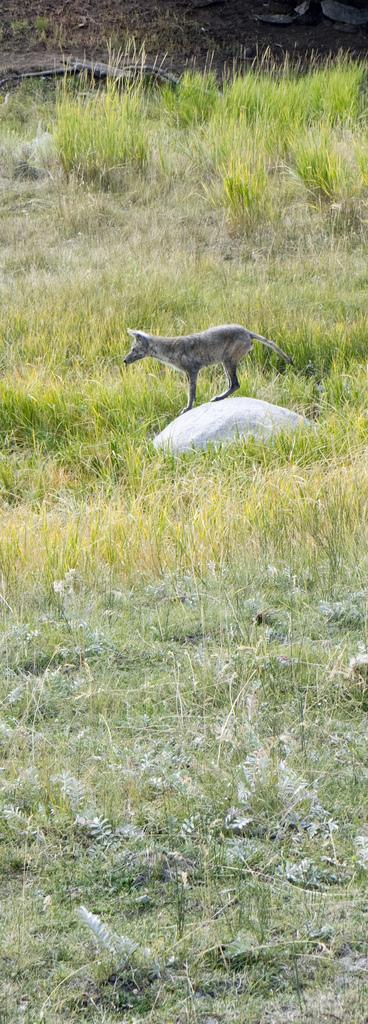What type of creature is in the image? There is an animal in the image. What is the animal standing on? The animal is standing on a stone. Where is the stone located? The stone is in the middle of grass. What type of milk is being poured on the animal in the image? There is no milk being poured on the animal in the image. What organization is responsible for the animal's care in the image? There is no information about an organization responsible for the animal's care in the image. 